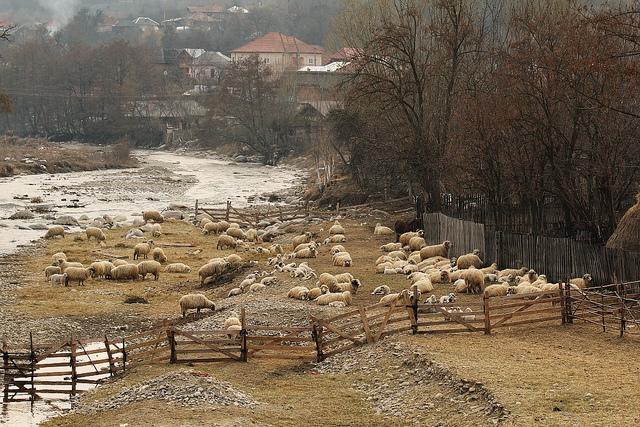Where was this taken place?
Answer briefly. Farm. Are the leaves on the trees green?
Answer briefly. No. Do you see a fence?
Be succinct. Yes. What color are the trees?
Concise answer only. Brown. What kind of animal is this?
Concise answer only. Sheep. How many animals are in the pen?
Quick response, please. 40. Where are they sitting?
Short answer required. On ground. Are the animals migrating?
Be succinct. No. Are the gate and wall made of the same material?
Be succinct. Yes. 